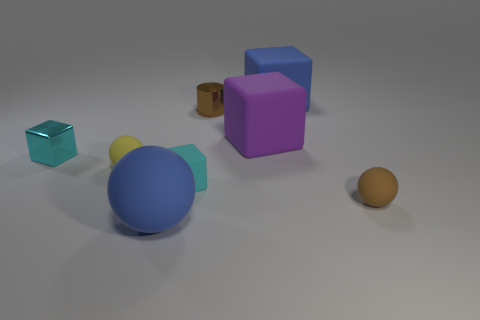Subtract all brown balls. How many cyan blocks are left? 2 Subtract all big blue matte balls. How many balls are left? 2 Add 1 big blocks. How many objects exist? 9 Subtract all cyan blocks. How many blocks are left? 2 Subtract all balls. How many objects are left? 5 Add 8 small brown metallic cylinders. How many small brown metallic cylinders are left? 9 Add 7 big brown metallic things. How many big brown metallic things exist? 7 Subtract 0 red spheres. How many objects are left? 8 Subtract all green balls. Subtract all gray cubes. How many balls are left? 3 Subtract all cyan objects. Subtract all small objects. How many objects are left? 1 